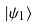<formula> <loc_0><loc_0><loc_500><loc_500>\left | \psi _ { 1 } \right \rangle</formula> 